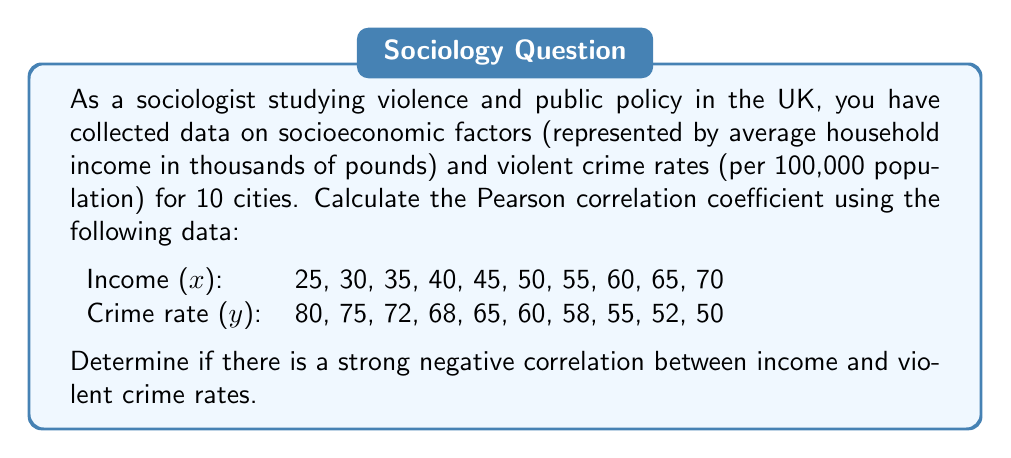Show me your answer to this math problem. To calculate the Pearson correlation coefficient, we'll use the formula:

$$ r = \frac{n\sum xy - (\sum x)(\sum y)}{\sqrt{[n\sum x^2 - (\sum x)^2][n\sum y^2 - (\sum y)^2]}} $$

Step 1: Calculate the sums and squared sums:
$\sum x = 475$
$\sum y = 635$
$\sum x^2 = 24,375$
$\sum y^2 = 41,013$
$\sum xy = 29,660$

Step 2: Calculate $n\sum xy$:
$n\sum xy = 10 \times 29,660 = 296,600$

Step 3: Calculate $(\sum x)(\sum y)$:
$(\sum x)(\sum y) = 475 \times 635 = 301,625$

Step 4: Calculate the numerator:
$n\sum xy - (\sum x)(\sum y) = 296,600 - 301,625 = -5,025$

Step 5: Calculate the denominator components:
$n\sum x^2 - (\sum x)^2 = 10 \times 24,375 - 475^2 = 18,750$
$n\sum y^2 - (\sum y)^2 = 10 \times 41,013 - 635^2 = 6,755$

Step 6: Calculate the denominator:
$\sqrt{[n\sum x^2 - (\sum x)^2][n\sum y^2 - (\sum y)^2]} = \sqrt{18,750 \times 6,755} = 11,258.85$

Step 7: Calculate the correlation coefficient:
$r = \frac{-5,025}{11,258.85} = -0.9946$

The correlation coefficient is approximately -0.9946, which indicates a very strong negative correlation between income and violent crime rates.
Answer: $r \approx -0.9946$ 